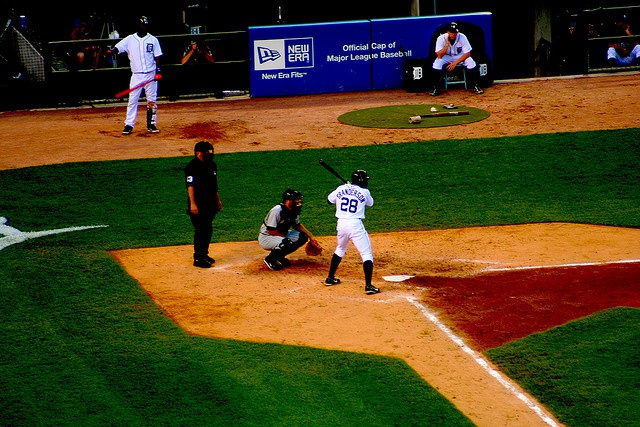Describe the objects in this image and their specific colors. I can see people in black, darkgreen, maroon, and red tones, people in black, darkgray, maroon, and gray tones, people in black, lavender, and violet tones, people in black, lavender, and violet tones, and people in black, lavender, and blue tones in this image. 